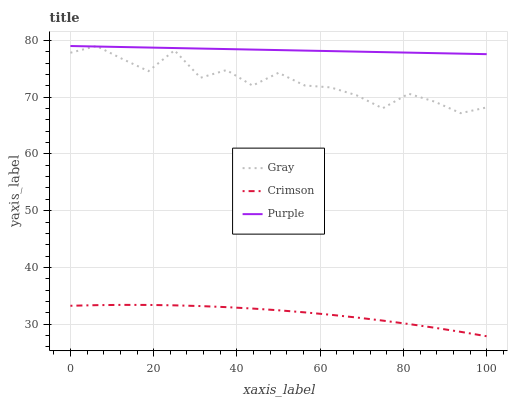Does Crimson have the minimum area under the curve?
Answer yes or no. Yes. Does Purple have the maximum area under the curve?
Answer yes or no. Yes. Does Gray have the minimum area under the curve?
Answer yes or no. No. Does Gray have the maximum area under the curve?
Answer yes or no. No. Is Purple the smoothest?
Answer yes or no. Yes. Is Gray the roughest?
Answer yes or no. Yes. Is Gray the smoothest?
Answer yes or no. No. Is Purple the roughest?
Answer yes or no. No. Does Crimson have the lowest value?
Answer yes or no. Yes. Does Gray have the lowest value?
Answer yes or no. No. Does Purple have the highest value?
Answer yes or no. Yes. Is Crimson less than Gray?
Answer yes or no. Yes. Is Gray greater than Crimson?
Answer yes or no. Yes. Does Gray intersect Purple?
Answer yes or no. Yes. Is Gray less than Purple?
Answer yes or no. No. Is Gray greater than Purple?
Answer yes or no. No. Does Crimson intersect Gray?
Answer yes or no. No. 